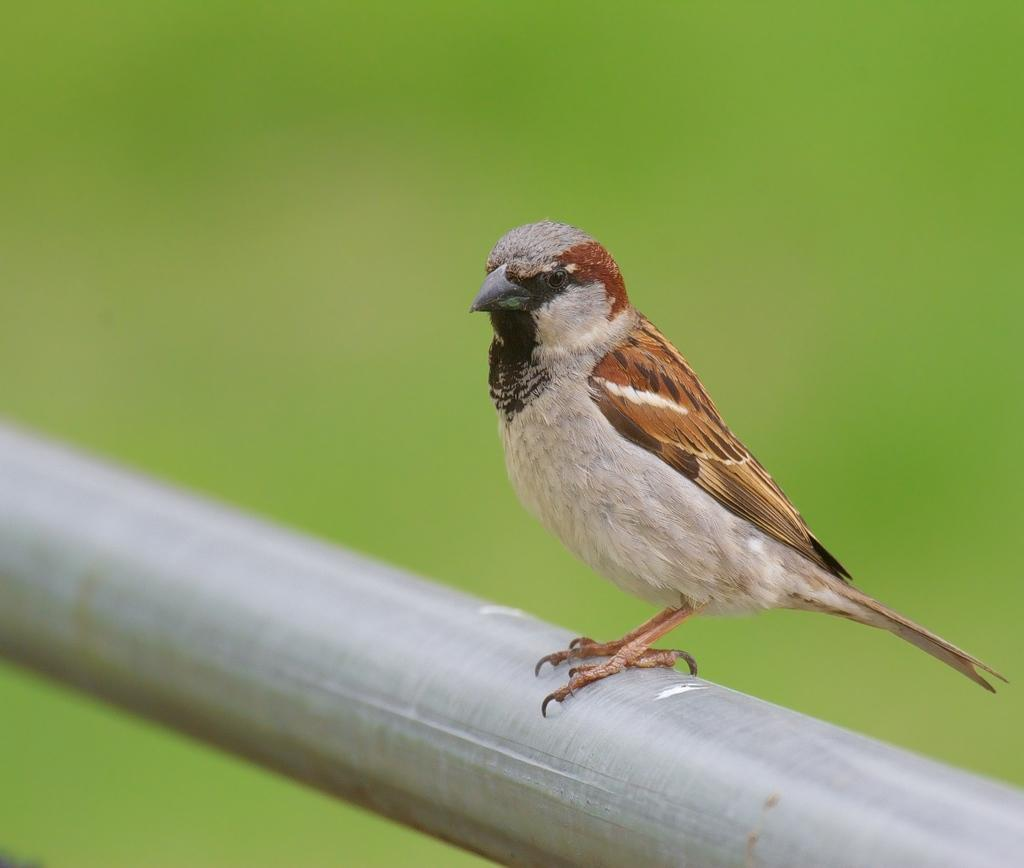What type of animal is in the image? There is a bird in the image. Where is the bird located? The bird is on a rod. Can you describe the background of the image? The background of the image is blurry. What type of wristwatch can be seen on the bird's leg in the image? There is no wristwatch present on the bird's leg in the image. Can you describe the playground equipment visible in the background of the image? There is no playground equipment visible in the image; the background is blurry. 